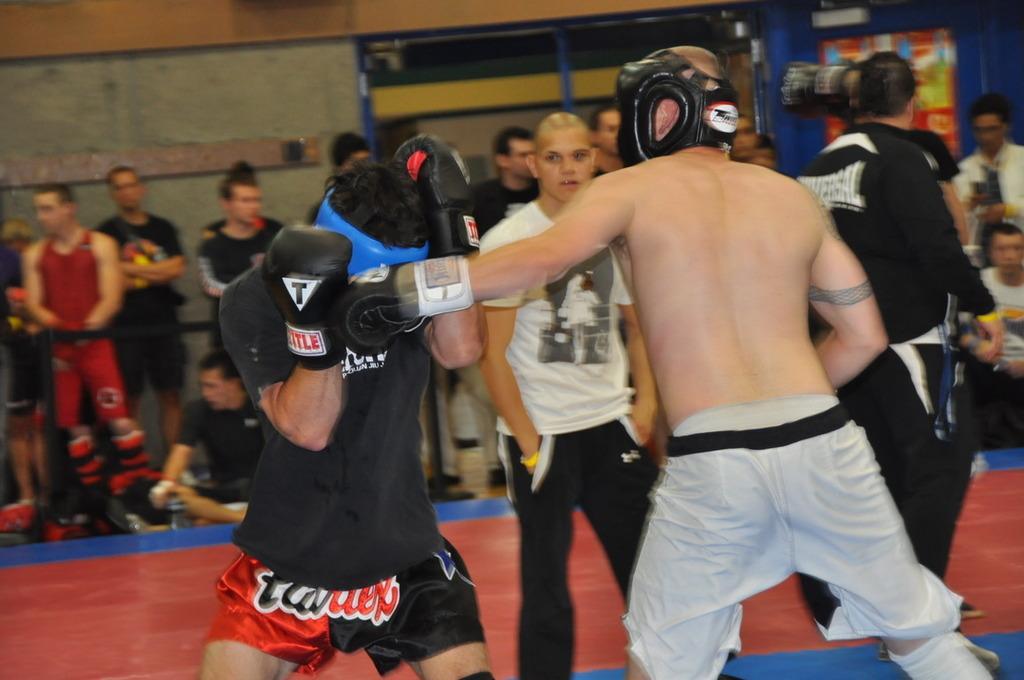Could you give a brief overview of what you see in this image? In this picture I can see few people are standing and couple of them sitting and I can see a wall in the background and a banner on the wall. 